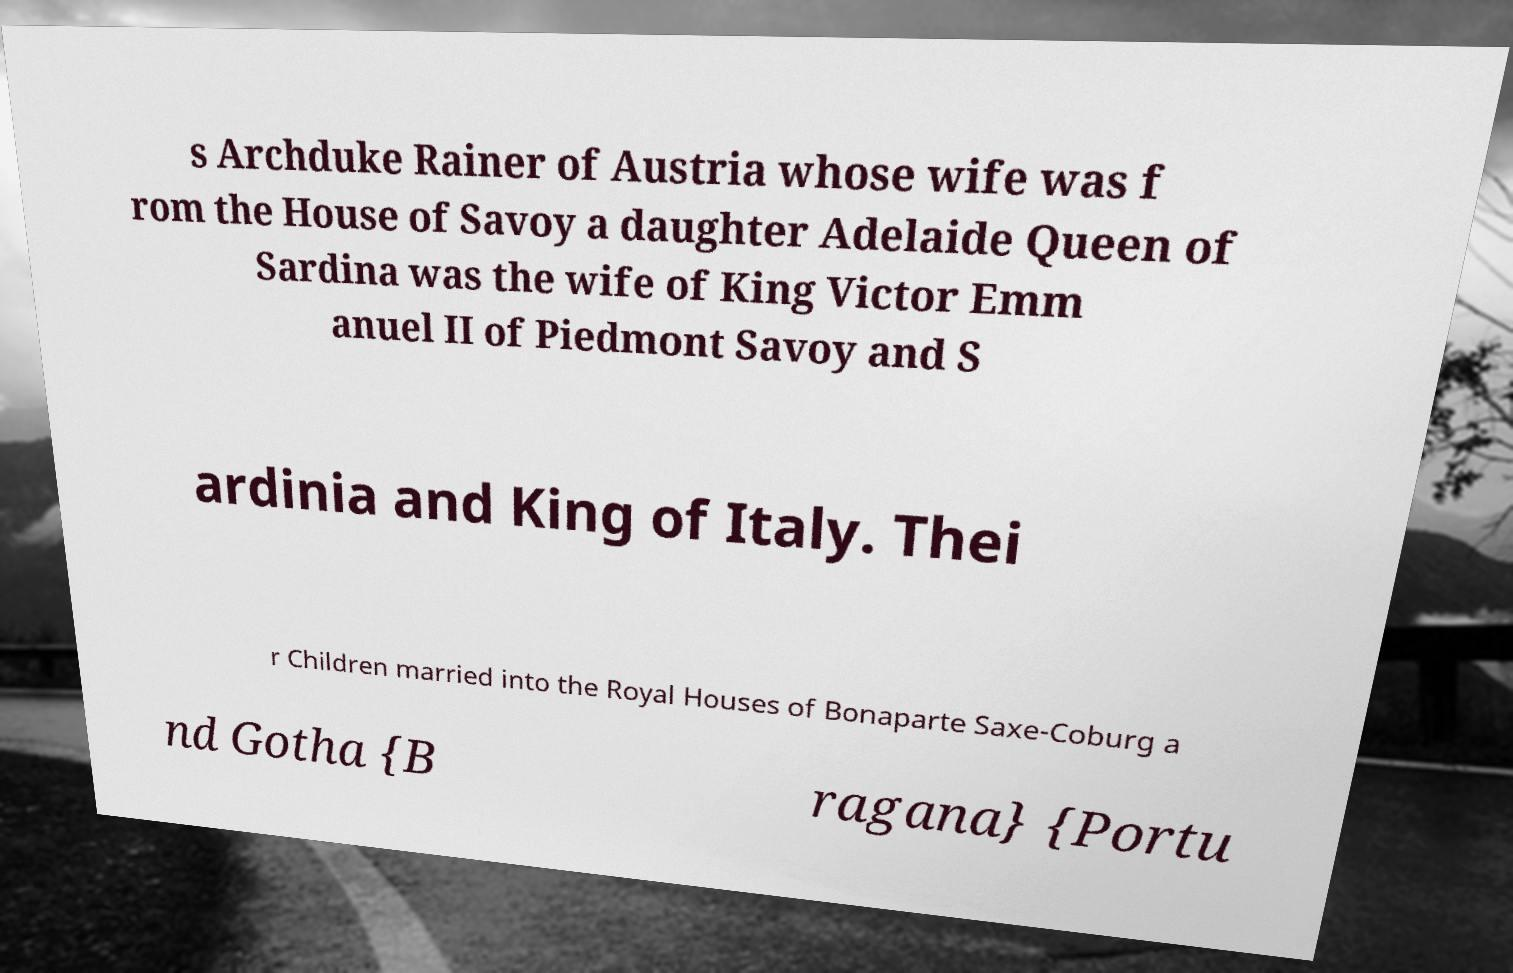Could you assist in decoding the text presented in this image and type it out clearly? s Archduke Rainer of Austria whose wife was f rom the House of Savoy a daughter Adelaide Queen of Sardina was the wife of King Victor Emm anuel II of Piedmont Savoy and S ardinia and King of Italy. Thei r Children married into the Royal Houses of Bonaparte Saxe-Coburg a nd Gotha {B ragana} {Portu 